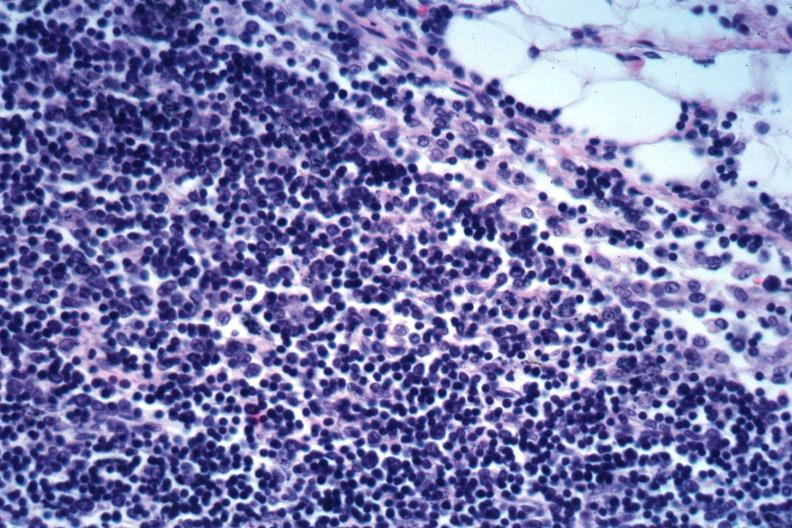what is present?
Answer the question using a single word or phrase. Malignant lymphoma 